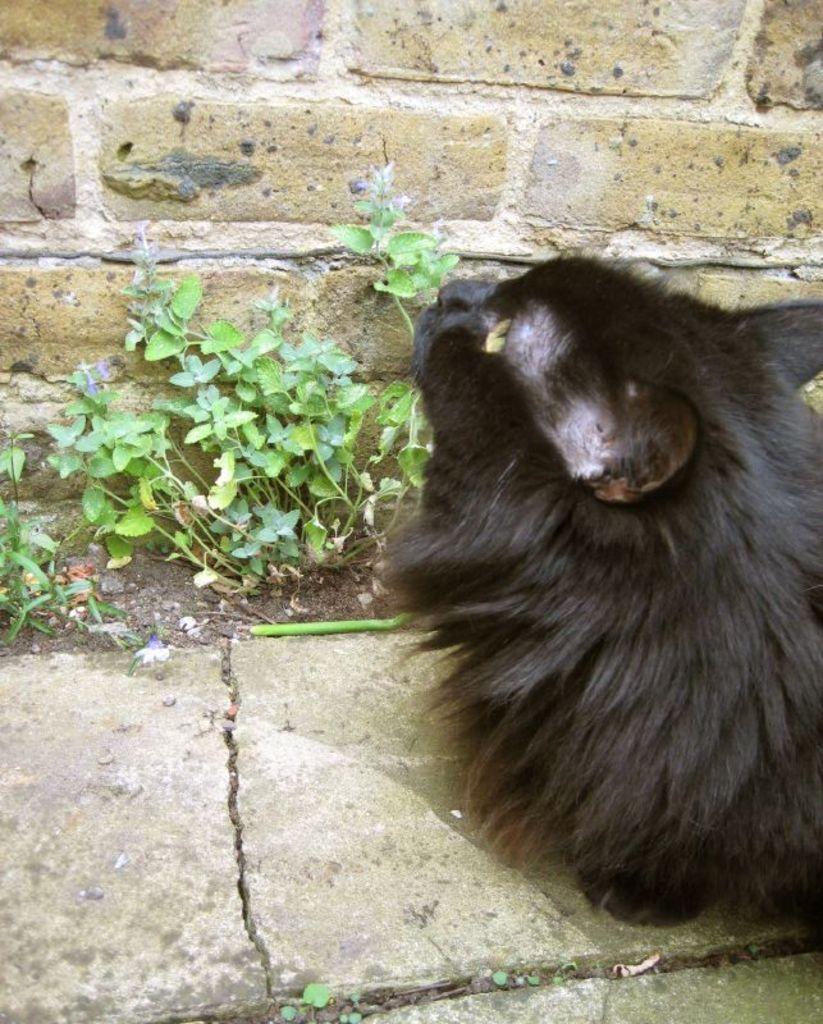Could you give a brief overview of what you see in this image? In this image I can see an animal which is in black color. In-front of the animal I can see the plants and the wall. 